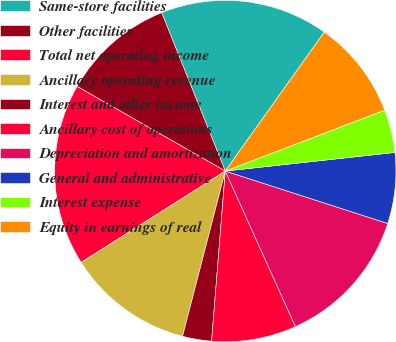<chart> <loc_0><loc_0><loc_500><loc_500><pie_chart><fcel>Same-store facilities<fcel>Other facilities<fcel>Total net operating income<fcel>Ancillary operating revenue<fcel>Interest and other income<fcel>Ancillary cost of operations<fcel>Depreciation and amortization<fcel>General and administrative<fcel>Interest expense<fcel>Equity in earnings of real<nl><fcel>15.93%<fcel>10.66%<fcel>17.25%<fcel>11.98%<fcel>2.75%<fcel>8.02%<fcel>13.29%<fcel>6.71%<fcel>4.07%<fcel>9.34%<nl></chart> 